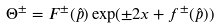Convert formula to latex. <formula><loc_0><loc_0><loc_500><loc_500>\Theta ^ { \pm } = F ^ { \pm } ( \hat { p } ) \exp ( { \pm } 2 x + f ^ { \pm } ( \hat { p } ) )</formula> 